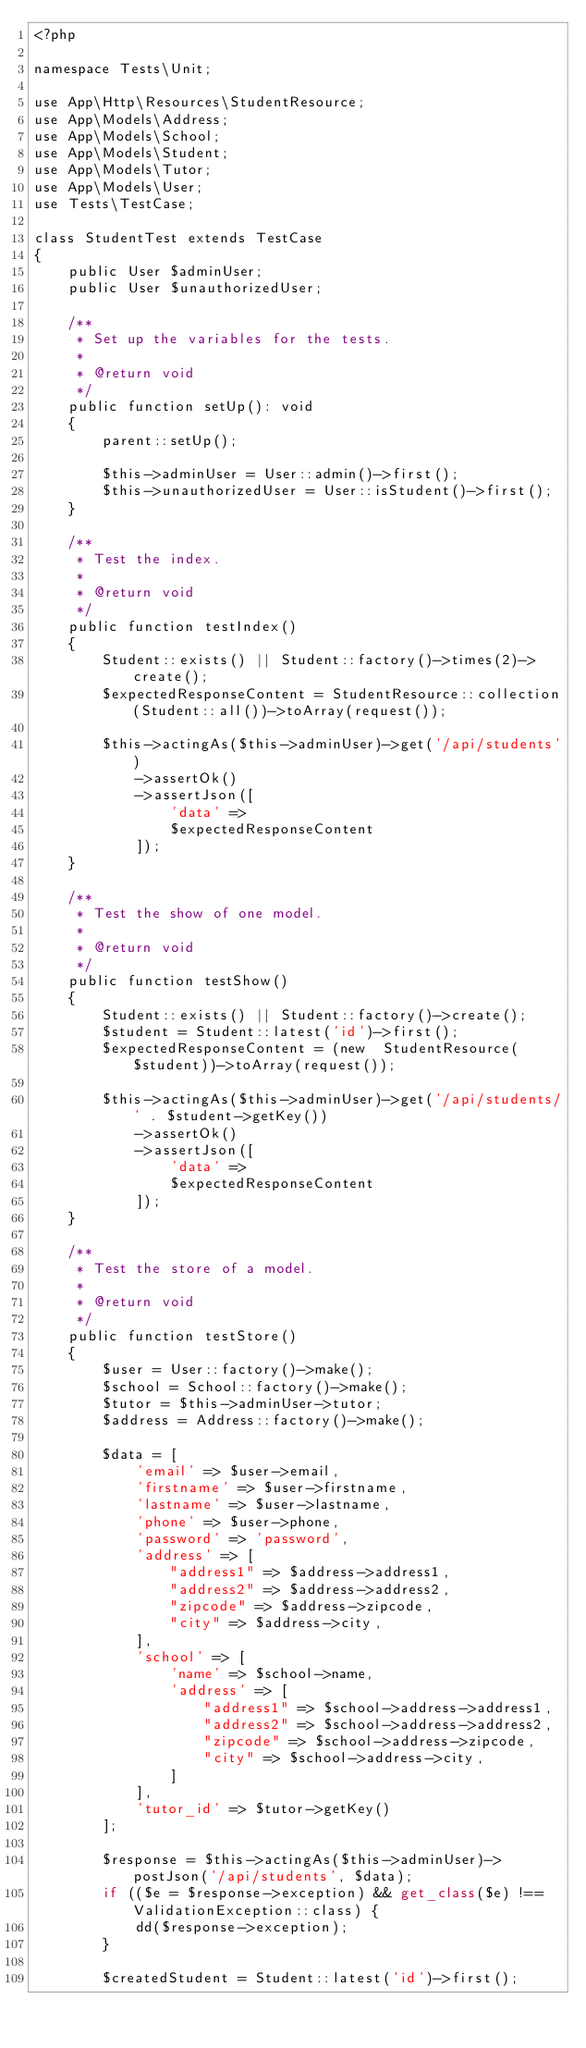Convert code to text. <code><loc_0><loc_0><loc_500><loc_500><_PHP_><?php

namespace Tests\Unit;

use App\Http\Resources\StudentResource;
use App\Models\Address;
use App\Models\School;
use App\Models\Student;
use App\Models\Tutor;
use App\Models\User;
use Tests\TestCase;

class StudentTest extends TestCase
{
    public User $adminUser;
    public User $unauthorizedUser;

    /**
     * Set up the variables for the tests.
     *
     * @return void
     */
    public function setUp(): void
    {
        parent::setUp();

        $this->adminUser = User::admin()->first();
        $this->unauthorizedUser = User::isStudent()->first();
    }

    /**
     * Test the index.
     *
     * @return void
     */
    public function testIndex()
    {
        Student::exists() || Student::factory()->times(2)->create();
        $expectedResponseContent = StudentResource::collection(Student::all())->toArray(request());

        $this->actingAs($this->adminUser)->get('/api/students')
            ->assertOk()
            ->assertJson([
                'data' =>
                $expectedResponseContent
            ]);
    }

    /**
     * Test the show of one model.
     *
     * @return void
     */
    public function testShow()
    {
        Student::exists() || Student::factory()->create();
        $student = Student::latest('id')->first();
        $expectedResponseContent = (new  StudentResource($student))->toArray(request());

        $this->actingAs($this->adminUser)->get('/api/students/' . $student->getKey())
            ->assertOk()
            ->assertJson([
                'data' =>
                $expectedResponseContent
            ]);
    }

    /**
     * Test the store of a model.
     *
     * @return void
     */
    public function testStore()
    {
        $user = User::factory()->make();
        $school = School::factory()->make();
        $tutor = $this->adminUser->tutor;
        $address = Address::factory()->make();

        $data = [
            'email' => $user->email,
            'firstname' => $user->firstname,
            'lastname' => $user->lastname,
            'phone' => $user->phone,
            'password' => 'password',
            'address' => [
                "address1" => $address->address1,
                "address2" => $address->address2,
                "zipcode" => $address->zipcode,
                "city" => $address->city,
            ],
            'school' => [
                'name' => $school->name,
                'address' => [
                    "address1" => $school->address->address1,
                    "address2" => $school->address->address2,
                    "zipcode" => $school->address->zipcode,
                    "city" => $school->address->city,
                ]
            ],
            'tutor_id' => $tutor->getKey()
        ];

        $response = $this->actingAs($this->adminUser)->postJson('/api/students', $data);
        if (($e = $response->exception) && get_class($e) !== ValidationException::class) {
            dd($response->exception);
        }

        $createdStudent = Student::latest('id')->first();
</code> 